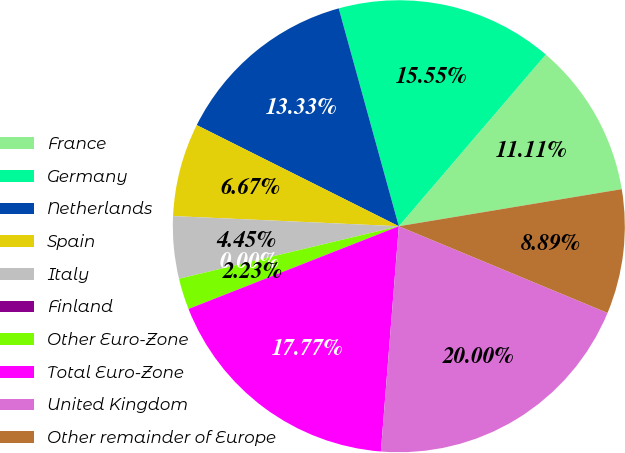Convert chart to OTSL. <chart><loc_0><loc_0><loc_500><loc_500><pie_chart><fcel>France<fcel>Germany<fcel>Netherlands<fcel>Spain<fcel>Italy<fcel>Finland<fcel>Other Euro-Zone<fcel>Total Euro-Zone<fcel>United Kingdom<fcel>Other remainder of Europe<nl><fcel>11.11%<fcel>15.55%<fcel>13.33%<fcel>6.67%<fcel>4.45%<fcel>0.0%<fcel>2.23%<fcel>17.77%<fcel>20.0%<fcel>8.89%<nl></chart> 